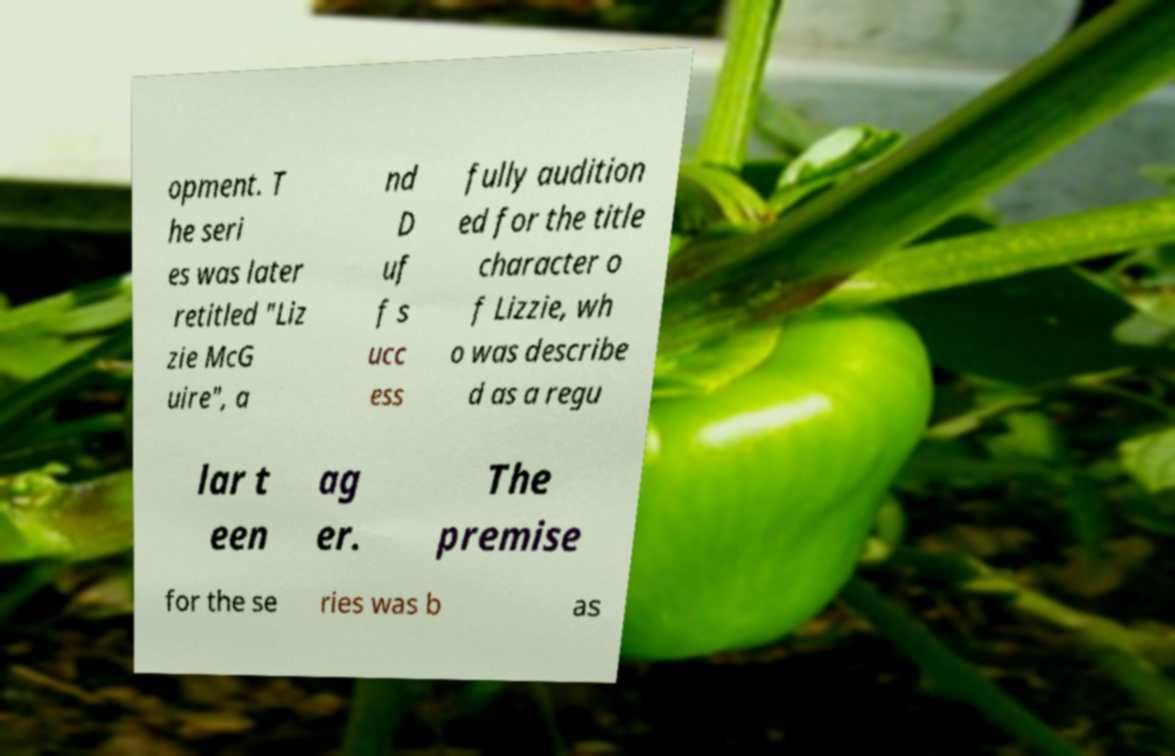I need the written content from this picture converted into text. Can you do that? opment. T he seri es was later retitled "Liz zie McG uire", a nd D uf f s ucc ess fully audition ed for the title character o f Lizzie, wh o was describe d as a regu lar t een ag er. The premise for the se ries was b as 